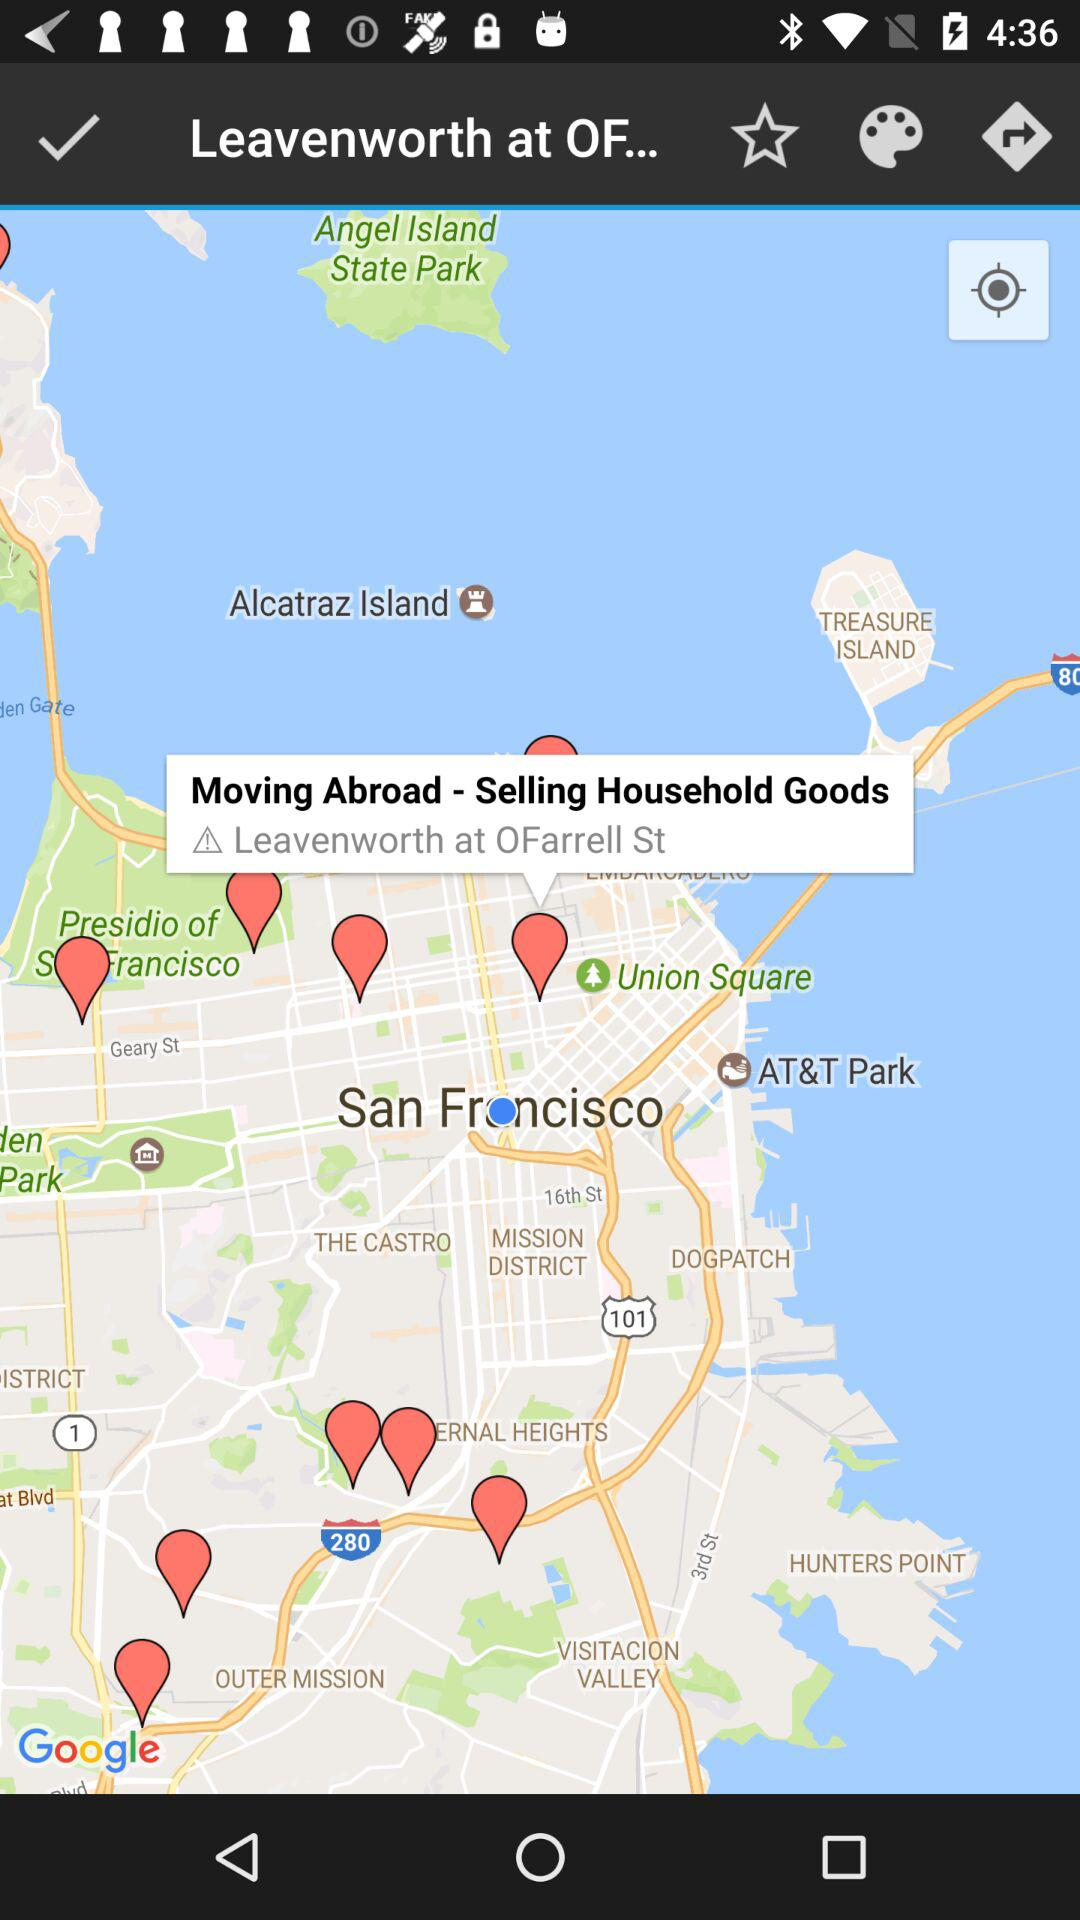How far away is Union Square?
When the provided information is insufficient, respond with <no answer>. <no answer> 